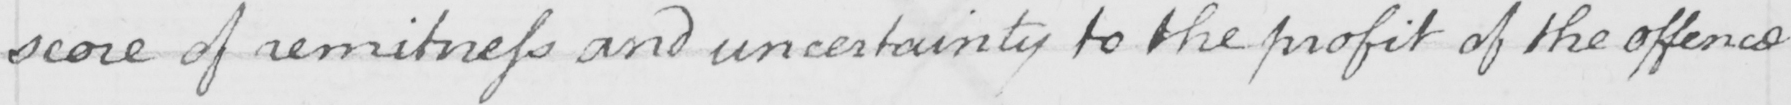Please provide the text content of this handwritten line. score of remitness and uncertainty to the profit of the offence 